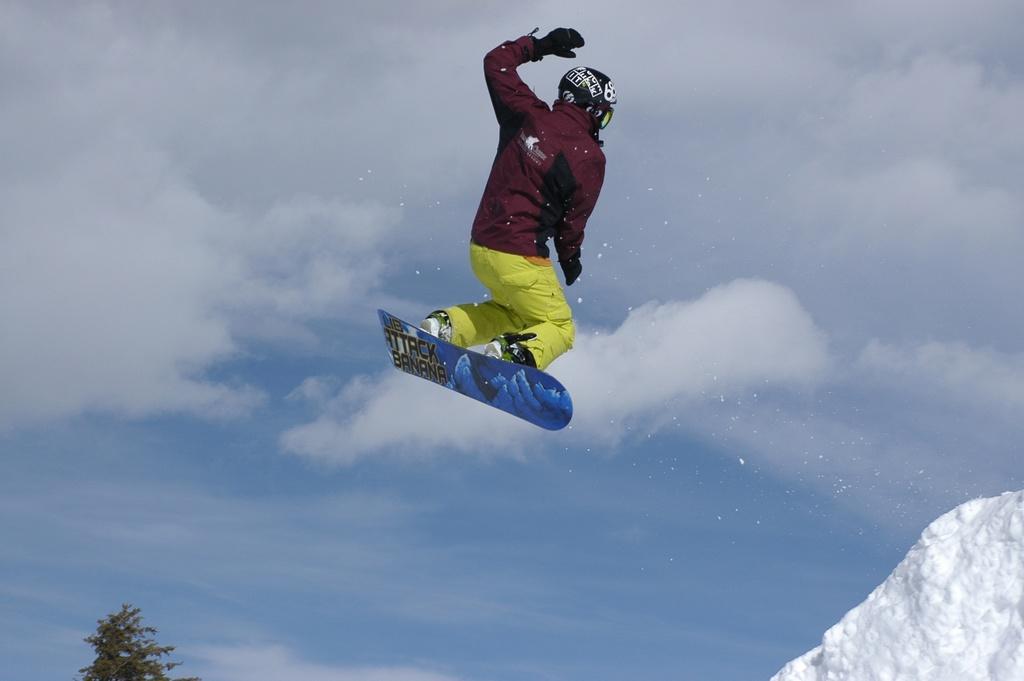How would you summarize this image in a sentence or two? In this image we can see a person in the air with the skateboard. In the background we can see the sky with clouds. We can also see the tree and snow at the bottom. 